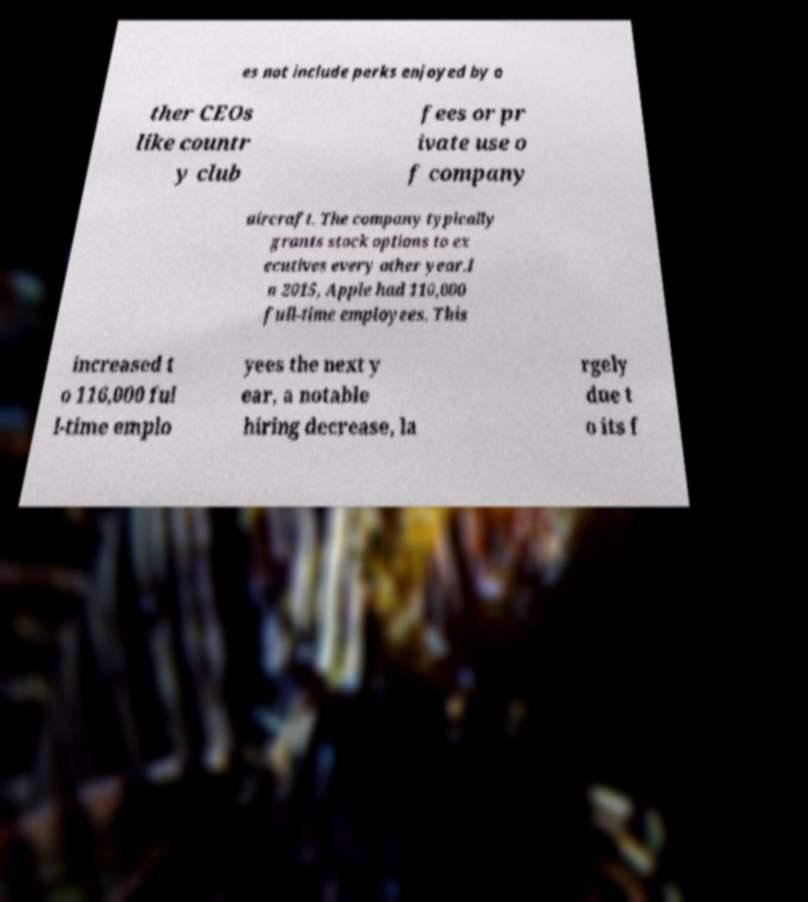Could you extract and type out the text from this image? es not include perks enjoyed by o ther CEOs like countr y club fees or pr ivate use o f company aircraft. The company typically grants stock options to ex ecutives every other year.I n 2015, Apple had 110,000 full-time employees. This increased t o 116,000 ful l-time emplo yees the next y ear, a notable hiring decrease, la rgely due t o its f 